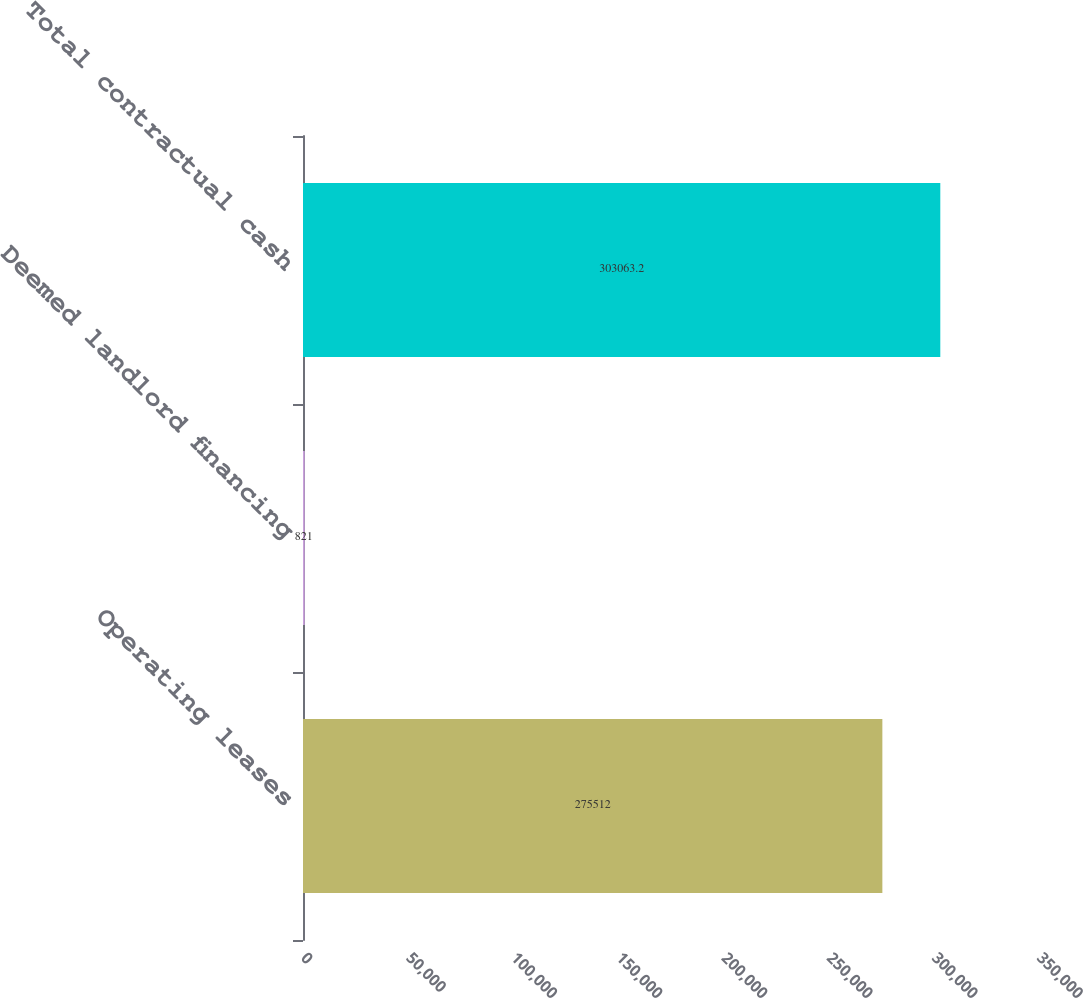<chart> <loc_0><loc_0><loc_500><loc_500><bar_chart><fcel>Operating leases<fcel>Deemed landlord financing<fcel>Total contractual cash<nl><fcel>275512<fcel>821<fcel>303063<nl></chart> 